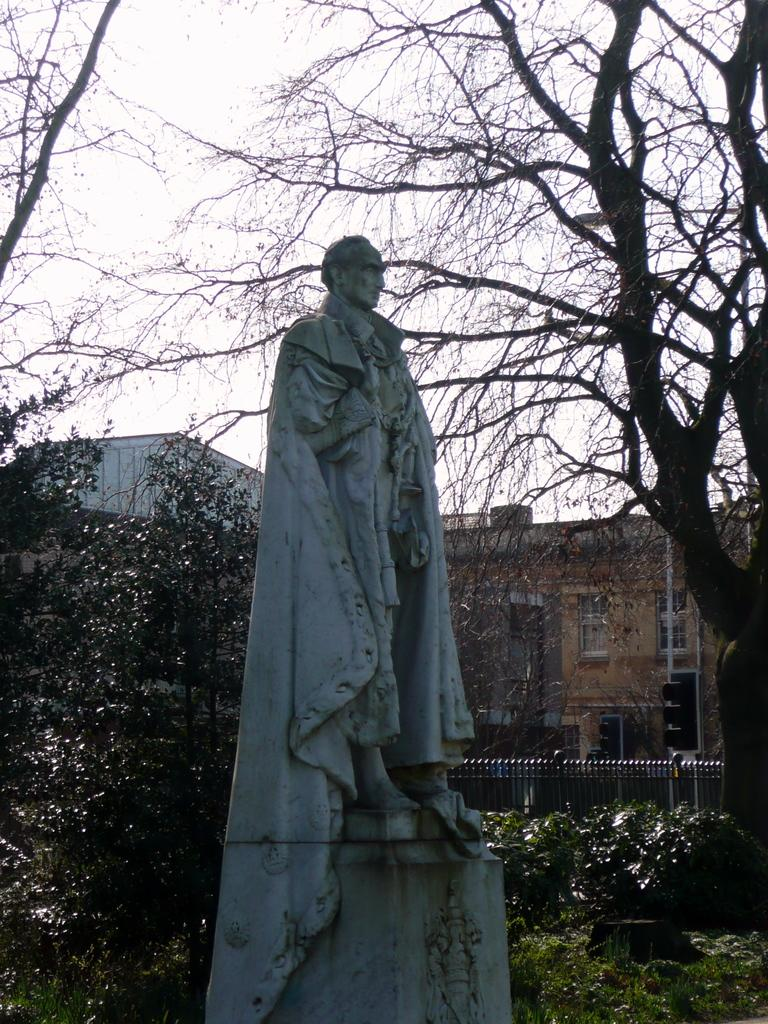What is the main subject in the image? There is a sculpture in the image. What other elements can be seen in the image besides the sculpture? There are plants, trees, traffic lights, and a fence visible in the image. What is the natural environment like in the image? The image features plants and trees. What can be seen in the background of the image? The sky is visible in the background of the image. What type of religious ceremony is taking place in the image? There is no indication of a religious ceremony in the image; it features a sculpture, plants, trees, traffic lights, a fence, and the sky. Can you see any monkeys interacting with the sculpture in the image? There are no monkeys present in the image. 